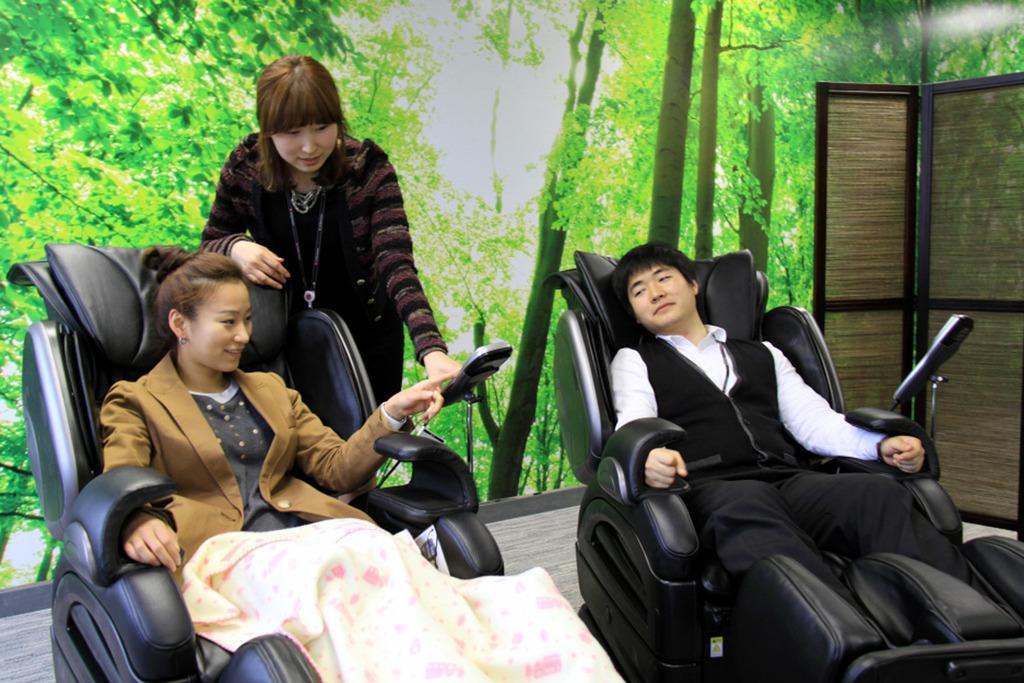In one or two sentences, can you explain what this image depicts? There are two persons sitting in massage chair and there is a woman standing behind them and the ground is green in color. 